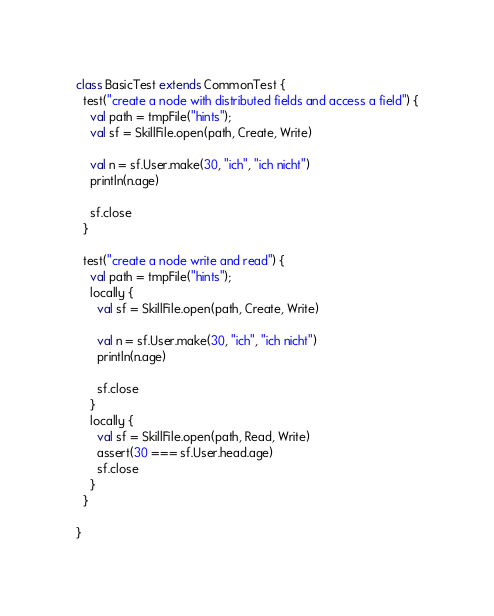Convert code to text. <code><loc_0><loc_0><loc_500><loc_500><_Scala_>class BasicTest extends CommonTest {
  test("create a node with distributed fields and access a field") {
    val path = tmpFile("hints");
    val sf = SkillFile.open(path, Create, Write)

    val n = sf.User.make(30, "ich", "ich nicht")
    println(n.age)

    sf.close
  }

  test("create a node write and read") {
    val path = tmpFile("hints");
    locally {
      val sf = SkillFile.open(path, Create, Write)

      val n = sf.User.make(30, "ich", "ich nicht")
      println(n.age)

      sf.close
    }
    locally {
      val sf = SkillFile.open(path, Read, Write)
      assert(30 === sf.User.head.age)
      sf.close
    }
  }

}
</code> 